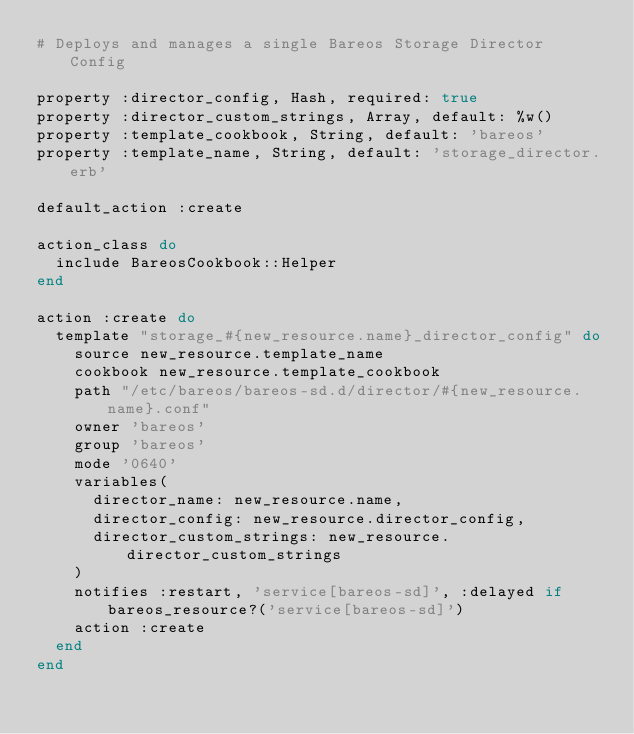<code> <loc_0><loc_0><loc_500><loc_500><_Ruby_># Deploys and manages a single Bareos Storage Director Config

property :director_config, Hash, required: true
property :director_custom_strings, Array, default: %w()
property :template_cookbook, String, default: 'bareos'
property :template_name, String, default: 'storage_director.erb'

default_action :create

action_class do
  include BareosCookbook::Helper
end

action :create do
  template "storage_#{new_resource.name}_director_config" do
    source new_resource.template_name
    cookbook new_resource.template_cookbook
    path "/etc/bareos/bareos-sd.d/director/#{new_resource.name}.conf"
    owner 'bareos'
    group 'bareos'
    mode '0640'
    variables(
      director_name: new_resource.name,
      director_config: new_resource.director_config,
      director_custom_strings: new_resource.director_custom_strings
    )
    notifies :restart, 'service[bareos-sd]', :delayed if bareos_resource?('service[bareos-sd]')
    action :create
  end
end
</code> 